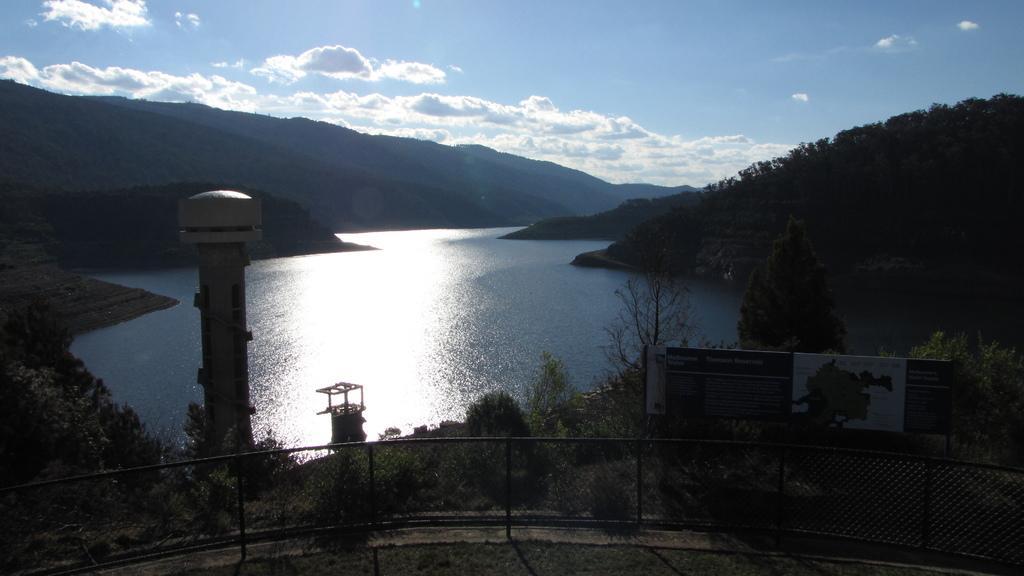Can you describe this image briefly? In this image, I can see water, hills, trees, plants and a tower. At the bottom of the image, I can see a fence and a board. In the background, there is the sky. 